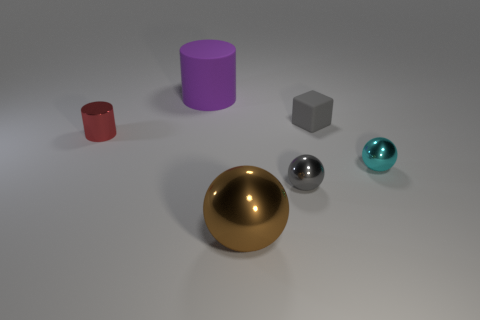Are there any other things that are the same color as the big metallic ball?
Offer a terse response. No. There is a thing that is the same material as the tiny gray block; what shape is it?
Provide a succinct answer. Cylinder. There is a tiny thing on the left side of the cylinder that is behind the red shiny thing; what number of red objects are in front of it?
Offer a very short reply. 0. The object that is behind the tiny metal cylinder and in front of the purple object has what shape?
Make the answer very short. Cube. Are there fewer metal balls that are on the left side of the tiny matte cube than metallic cylinders?
Ensure brevity in your answer.  No. How many small objects are gray metallic balls or red shiny cylinders?
Give a very brief answer. 2. How big is the rubber cylinder?
Provide a succinct answer. Large. How many gray objects are behind the purple matte thing?
Give a very brief answer. 0. What size is the purple object that is the same shape as the tiny red metallic thing?
Provide a short and direct response. Large. There is a shiny object that is behind the small gray ball and right of the red object; what is its size?
Offer a terse response. Small. 